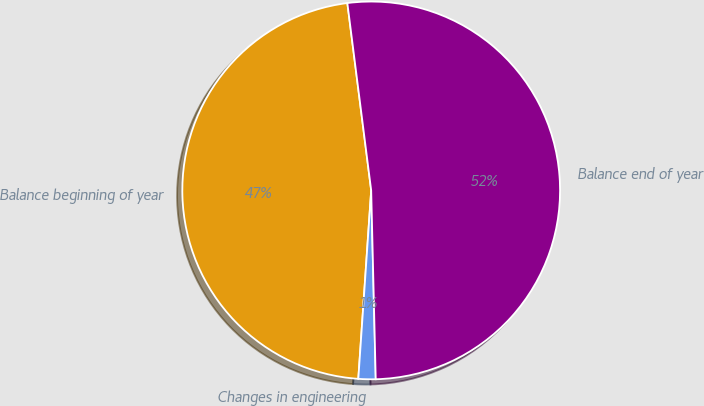Convert chart to OTSL. <chart><loc_0><loc_0><loc_500><loc_500><pie_chart><fcel>Balance beginning of year<fcel>Changes in engineering<fcel>Balance end of year<nl><fcel>46.9%<fcel>1.47%<fcel>51.63%<nl></chart> 